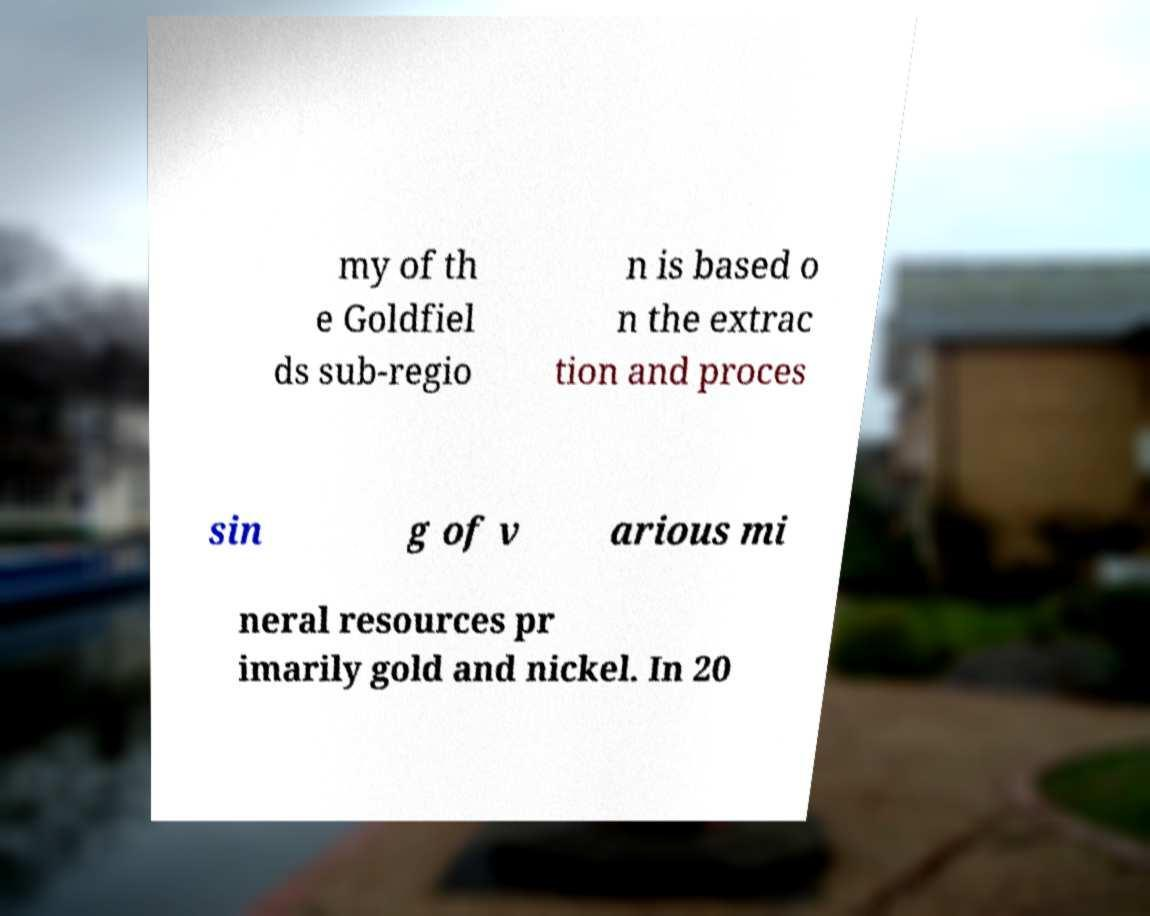I need the written content from this picture converted into text. Can you do that? my of th e Goldfiel ds sub-regio n is based o n the extrac tion and proces sin g of v arious mi neral resources pr imarily gold and nickel. In 20 